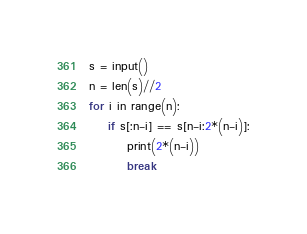<code> <loc_0><loc_0><loc_500><loc_500><_Python_>s = input()
n = len(s)//2
for i in range(n):
    if s[:n-i] == s[n-i:2*(n-i)]:
        print(2*(n-i))
        break</code> 